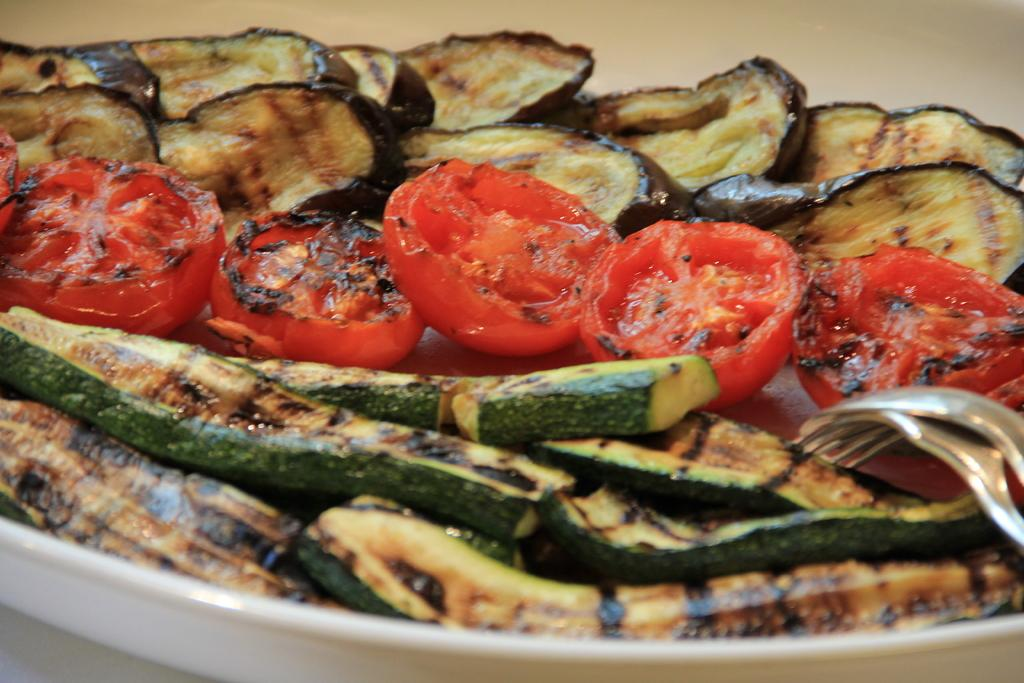What is the main object in the center of the image? There is a plate in the center of the image. What is on the plate? There are food items on the plate. Who is the owner of the rifle in the image? There is no rifle present in the image. 